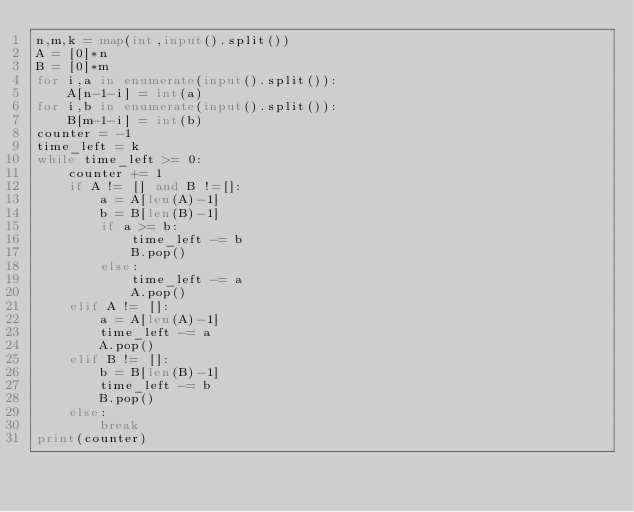Convert code to text. <code><loc_0><loc_0><loc_500><loc_500><_Python_>n,m,k = map(int,input().split())
A = [0]*n
B = [0]*m
for i,a in enumerate(input().split()):
    A[n-1-i] = int(a)
for i,b in enumerate(input().split()):
    B[m-1-i] = int(b)
counter = -1
time_left = k
while time_left >= 0:
    counter += 1
    if A != [] and B !=[]:
        a = A[len(A)-1]
        b = B[len(B)-1]
        if a >= b:
            time_left -= b
            B.pop()
        else:
            time_left -= a
            A.pop()
    elif A != []:
        a = A[len(A)-1]
        time_left -= a
        A.pop()
    elif B != []:
        b = B[len(B)-1]
        time_left -= b
        B.pop()
    else:
        break
print(counter)</code> 